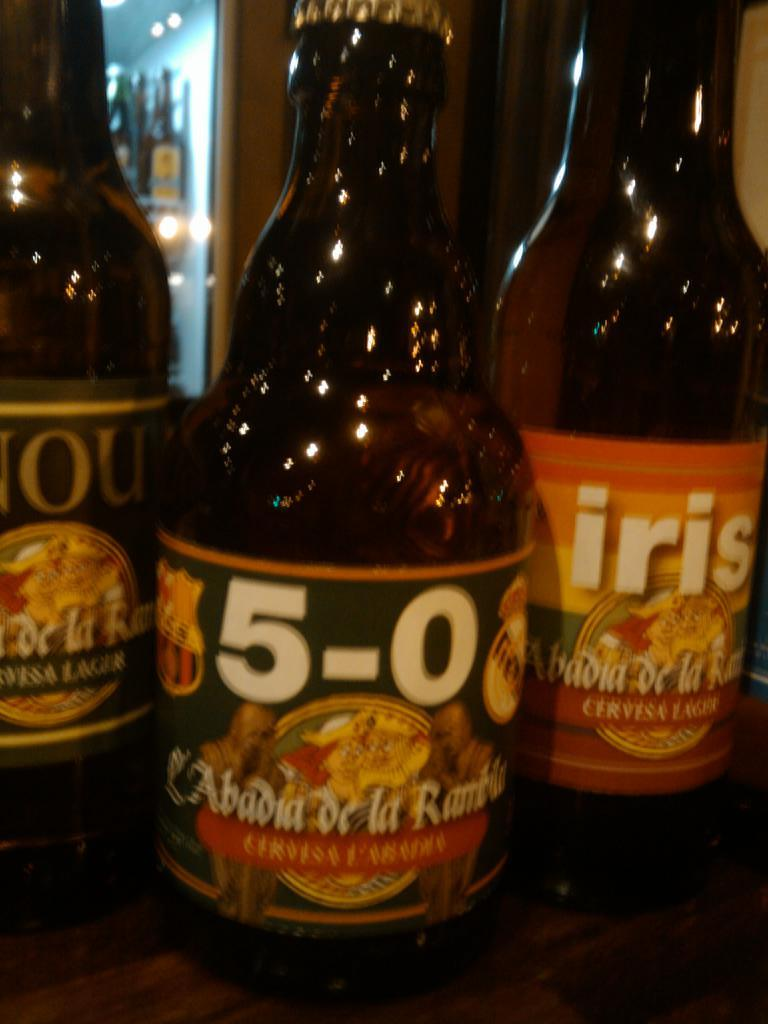Provide a one-sentence caption for the provided image. Three bottles and one which reads 5-0 on it. 